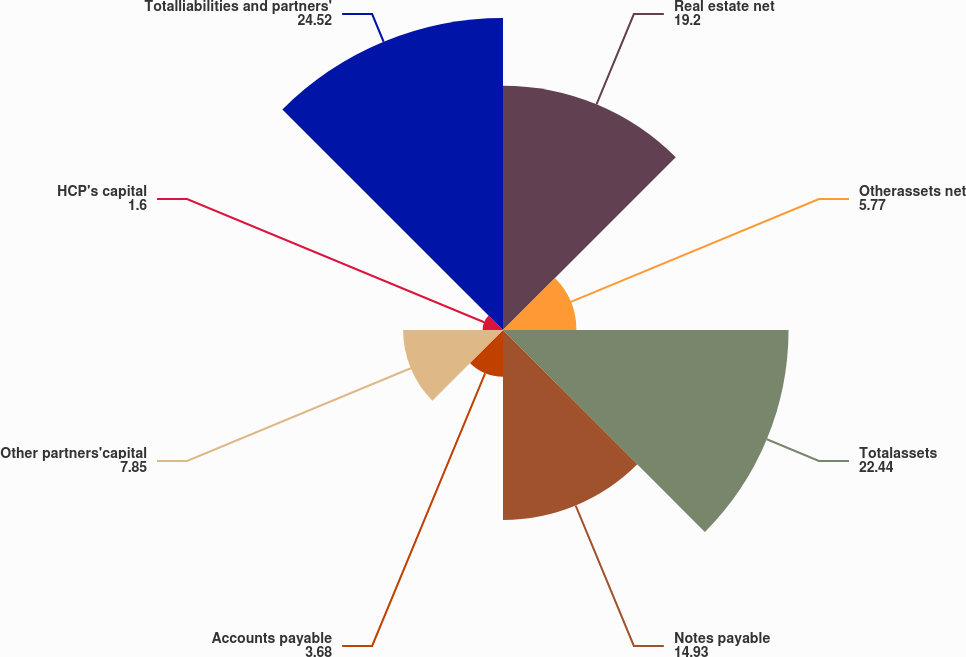Convert chart. <chart><loc_0><loc_0><loc_500><loc_500><pie_chart><fcel>Real estate net<fcel>Otherassets net<fcel>Totalassets<fcel>Notes payable<fcel>Accounts payable<fcel>Other partners'capital<fcel>HCP's capital<fcel>Totalliabilities and partners'<nl><fcel>19.2%<fcel>5.77%<fcel>22.44%<fcel>14.93%<fcel>3.68%<fcel>7.85%<fcel>1.6%<fcel>24.52%<nl></chart> 